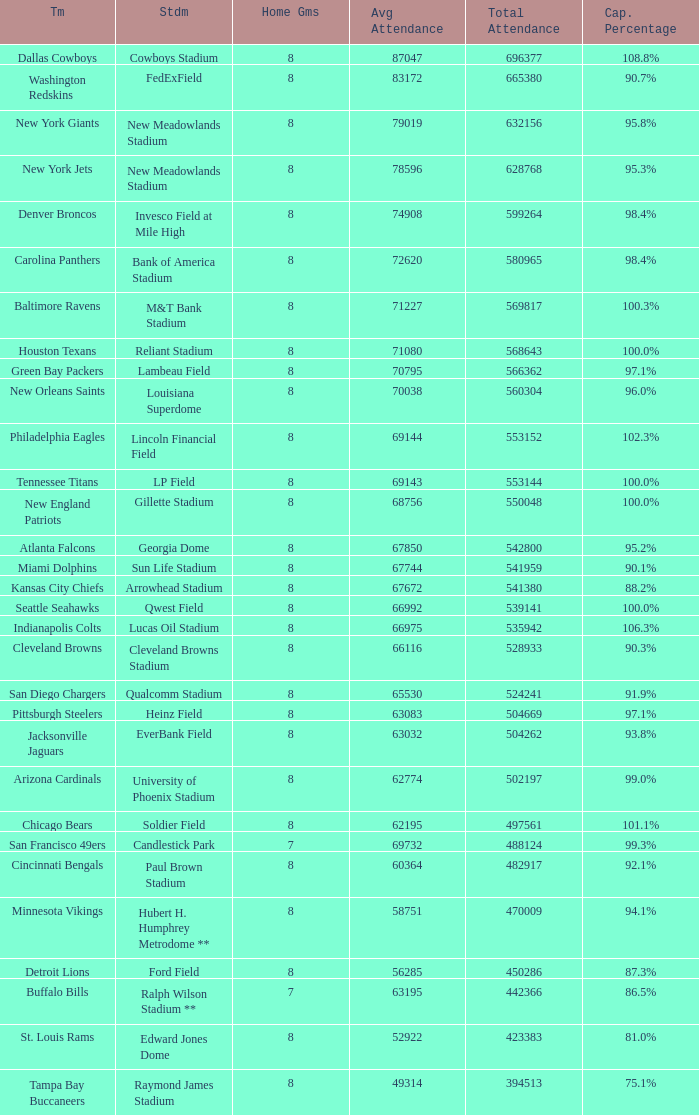Could you help me parse every detail presented in this table? {'header': ['Tm', 'Stdm', 'Home Gms', 'Avg Attendance', 'Total Attendance', 'Cap. Percentage'], 'rows': [['Dallas Cowboys', 'Cowboys Stadium', '8', '87047', '696377', '108.8%'], ['Washington Redskins', 'FedExField', '8', '83172', '665380', '90.7%'], ['New York Giants', 'New Meadowlands Stadium', '8', '79019', '632156', '95.8%'], ['New York Jets', 'New Meadowlands Stadium', '8', '78596', '628768', '95.3%'], ['Denver Broncos', 'Invesco Field at Mile High', '8', '74908', '599264', '98.4%'], ['Carolina Panthers', 'Bank of America Stadium', '8', '72620', '580965', '98.4%'], ['Baltimore Ravens', 'M&T Bank Stadium', '8', '71227', '569817', '100.3%'], ['Houston Texans', 'Reliant Stadium', '8', '71080', '568643', '100.0%'], ['Green Bay Packers', 'Lambeau Field', '8', '70795', '566362', '97.1%'], ['New Orleans Saints', 'Louisiana Superdome', '8', '70038', '560304', '96.0%'], ['Philadelphia Eagles', 'Lincoln Financial Field', '8', '69144', '553152', '102.3%'], ['Tennessee Titans', 'LP Field', '8', '69143', '553144', '100.0%'], ['New England Patriots', 'Gillette Stadium', '8', '68756', '550048', '100.0%'], ['Atlanta Falcons', 'Georgia Dome', '8', '67850', '542800', '95.2%'], ['Miami Dolphins', 'Sun Life Stadium', '8', '67744', '541959', '90.1%'], ['Kansas City Chiefs', 'Arrowhead Stadium', '8', '67672', '541380', '88.2%'], ['Seattle Seahawks', 'Qwest Field', '8', '66992', '539141', '100.0%'], ['Indianapolis Colts', 'Lucas Oil Stadium', '8', '66975', '535942', '106.3%'], ['Cleveland Browns', 'Cleveland Browns Stadium', '8', '66116', '528933', '90.3%'], ['San Diego Chargers', 'Qualcomm Stadium', '8', '65530', '524241', '91.9%'], ['Pittsburgh Steelers', 'Heinz Field', '8', '63083', '504669', '97.1%'], ['Jacksonville Jaguars', 'EverBank Field', '8', '63032', '504262', '93.8%'], ['Arizona Cardinals', 'University of Phoenix Stadium', '8', '62774', '502197', '99.0%'], ['Chicago Bears', 'Soldier Field', '8', '62195', '497561', '101.1%'], ['San Francisco 49ers', 'Candlestick Park', '7', '69732', '488124', '99.3%'], ['Cincinnati Bengals', 'Paul Brown Stadium', '8', '60364', '482917', '92.1%'], ['Minnesota Vikings', 'Hubert H. Humphrey Metrodome **', '8', '58751', '470009', '94.1%'], ['Detroit Lions', 'Ford Field', '8', '56285', '450286', '87.3%'], ['Buffalo Bills', 'Ralph Wilson Stadium **', '7', '63195', '442366', '86.5%'], ['St. Louis Rams', 'Edward Jones Dome', '8', '52922', '423383', '81.0%'], ['Tampa Bay Buccaneers', 'Raymond James Stadium', '8', '49314', '394513', '75.1%']]} What team had a capacity of 102.3%? Philadelphia Eagles. 